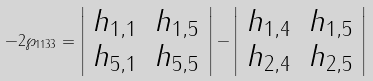Convert formula to latex. <formula><loc_0><loc_0><loc_500><loc_500>- 2 \wp _ { 1 1 3 3 } = \left | \begin{array} { c c } h _ { 1 , 1 } & h _ { 1 , 5 } \\ h _ { 5 , 1 } & h _ { 5 , 5 } \end{array} \right | - \left | \begin{array} { c c } h _ { 1 , 4 } & h _ { 1 , 5 } \\ h _ { 2 , 4 } & h _ { 2 , 5 } \end{array} \right |</formula> 